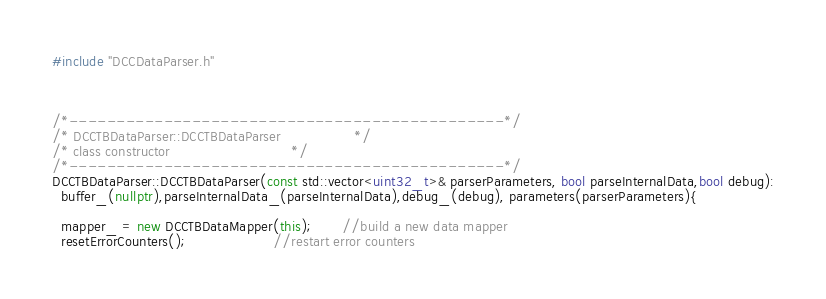Convert code to text. <code><loc_0><loc_0><loc_500><loc_500><_C++_>#include "DCCDataParser.h"



/*----------------------------------------------*/
/* DCCTBDataParser::DCCTBDataParser                 */
/* class constructor                            */
/*----------------------------------------------*/
DCCTBDataParser::DCCTBDataParser(const std::vector<uint32_t>& parserParameters, bool parseInternalData,bool debug):
  buffer_(nullptr),parseInternalData_(parseInternalData),debug_(debug), parameters(parserParameters){
	
  mapper_ = new DCCTBDataMapper(this);       //build a new data mapper
  resetErrorCounters();                    //restart error counters</code> 